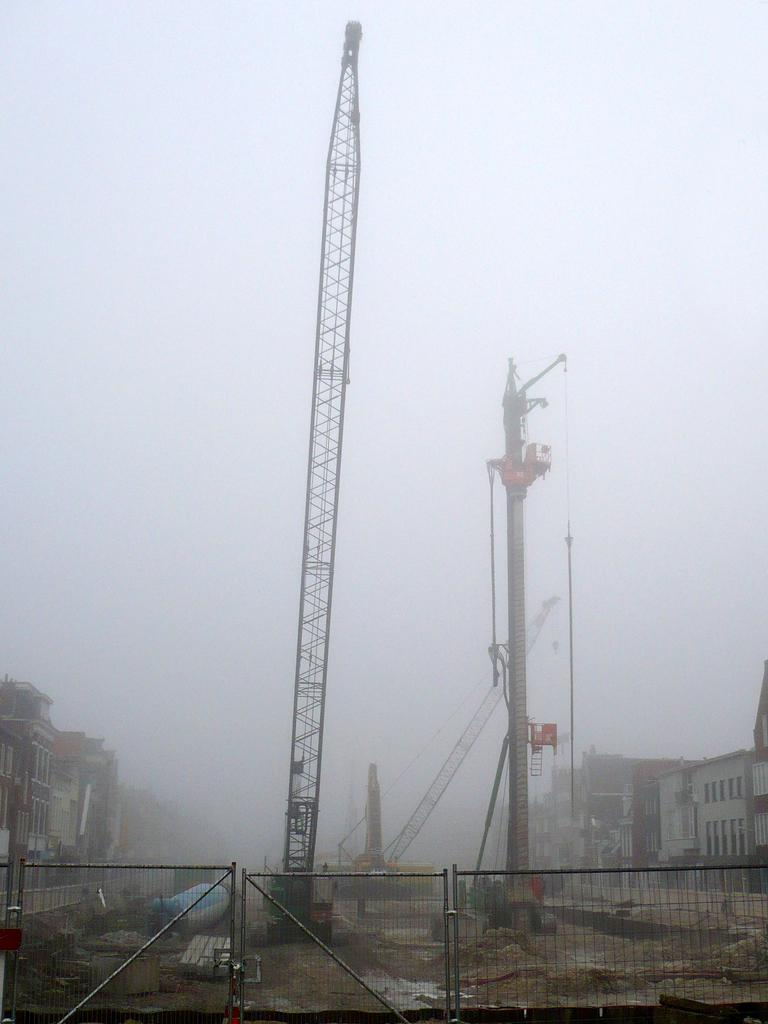What type of construction equipment can be seen in the image? There is a crane in the image. What structure is visible in the image? There is a building in the image. What other large machines are present in the image? There are big machines in the image. What is the weather condition in the image? There is fog in the image. What type of barrier is at the bottom of the image? There is fencing at the bottom of the image. What type of vegetable is being used as a protest sign in the image? There is no vegetable or protest sign present in the image. What is the calculator used for in the image? There is no calculator present in the image. 